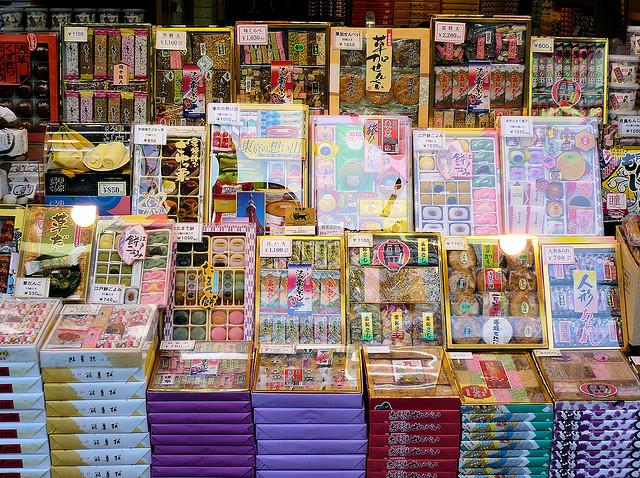Why are the boxes lined up and on display? to sell 